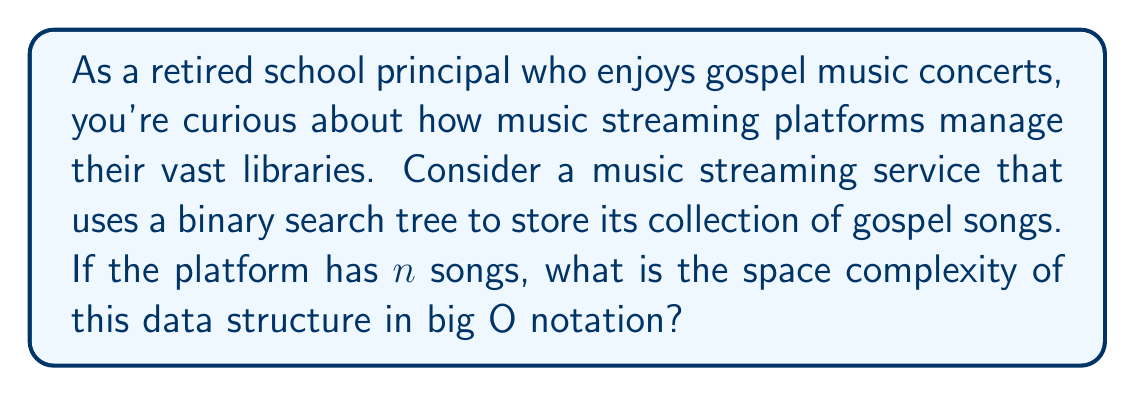What is the answer to this math problem? To understand the space complexity of a binary search tree (BST) used in a music streaming platform, let's break it down step-by-step:

1. Structure of a BST:
   - Each node in the BST represents a song
   - Each node contains:
     a) The song data (title, artist, etc.)
     b) Two pointers (left and right child)

2. Space required for each node:
   - Let's assume the song data takes constant space $c$
   - Each pointer typically requires 8 bytes on a 64-bit system
   - Total space per node: $S_{node} = c + 16$ bytes

3. Number of nodes:
   - For $n$ songs, we have $n$ nodes in the BST

4. Total space:
   - $S_{total} = n * S_{node} = n * (c + 16)$

5. Big O notation:
   - We ignore constants in big O notation
   - $S_{total} = O(n)$

This means that the space complexity grows linearly with the number of songs. As the music library expands, the space required increases proportionally.

For a balanced BST (which is ideal for efficient searching), the height of the tree would be $O(\log n)$, but this doesn't affect the overall space complexity, which remains $O(n)$.
Answer: The space complexity of a binary search tree used to store $n$ songs in a music streaming platform is $O(n)$. 